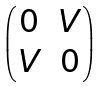<formula> <loc_0><loc_0><loc_500><loc_500>\begin{pmatrix} 0 & V \\ V & 0 \end{pmatrix}</formula> 